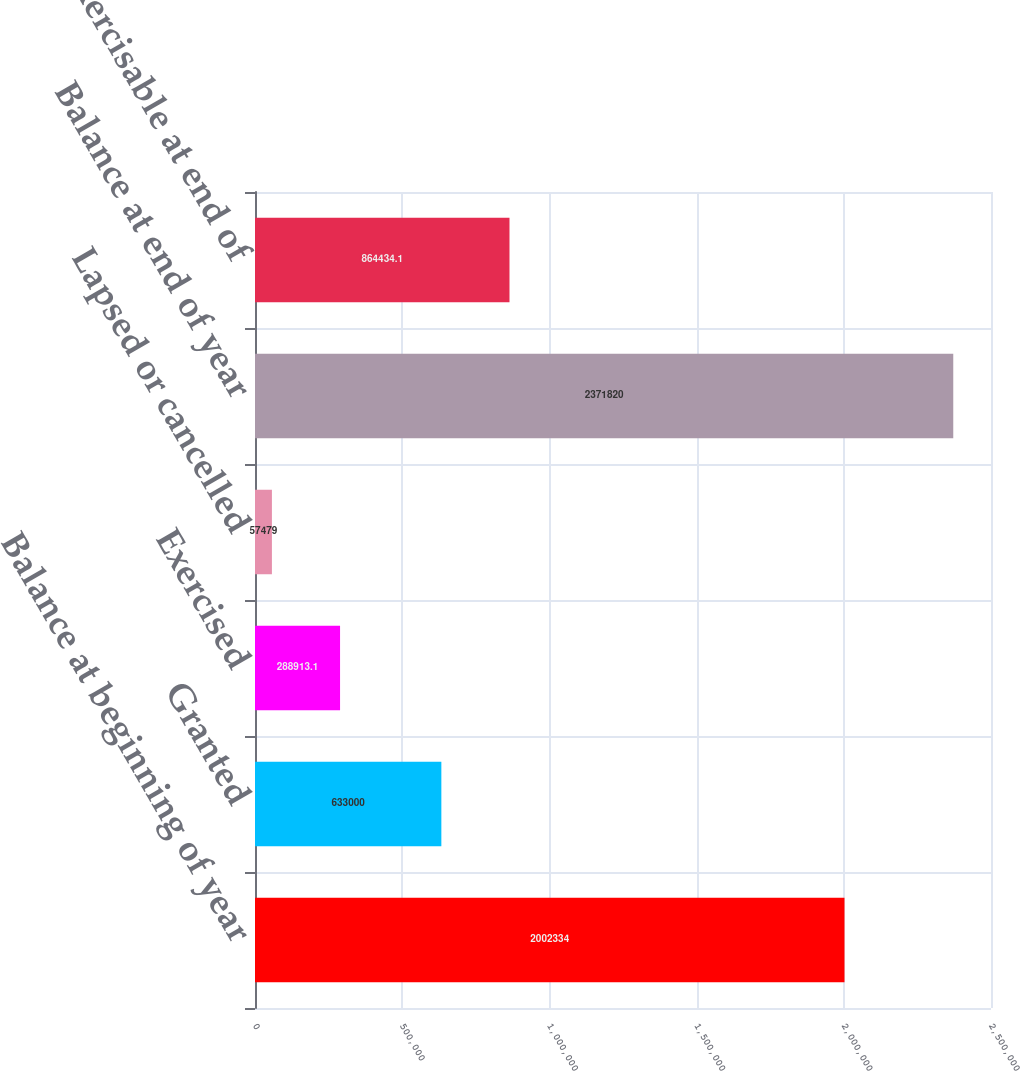<chart> <loc_0><loc_0><loc_500><loc_500><bar_chart><fcel>Balance at beginning of year<fcel>Granted<fcel>Exercised<fcel>Lapsed or cancelled<fcel>Balance at end of year<fcel>Options exercisable at end of<nl><fcel>2.00233e+06<fcel>633000<fcel>288913<fcel>57479<fcel>2.37182e+06<fcel>864434<nl></chart> 